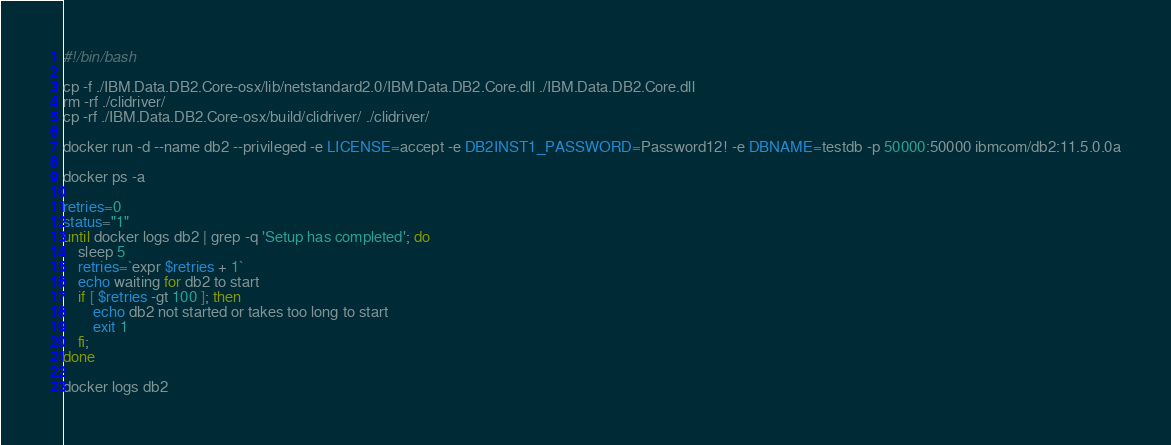Convert code to text. <code><loc_0><loc_0><loc_500><loc_500><_Bash_>#!/bin/bash

cp -f ./IBM.Data.DB2.Core-osx/lib/netstandard2.0/IBM.Data.DB2.Core.dll ./IBM.Data.DB2.Core.dll
rm -rf ./clidriver/
cp -rf ./IBM.Data.DB2.Core-osx/build/clidriver/ ./clidriver/

docker run -d --name db2 --privileged -e LICENSE=accept -e DB2INST1_PASSWORD=Password12! -e DBNAME=testdb -p 50000:50000 ibmcom/db2:11.5.0.0a

docker ps -a

retries=0
status="1"
until docker logs db2 | grep -q 'Setup has completed'; do
    sleep 5
    retries=`expr $retries + 1`
    echo waiting for db2 to start
    if [ $retries -gt 100 ]; then
        echo db2 not started or takes too long to start
        exit 1
    fi;
done

docker logs db2
</code> 